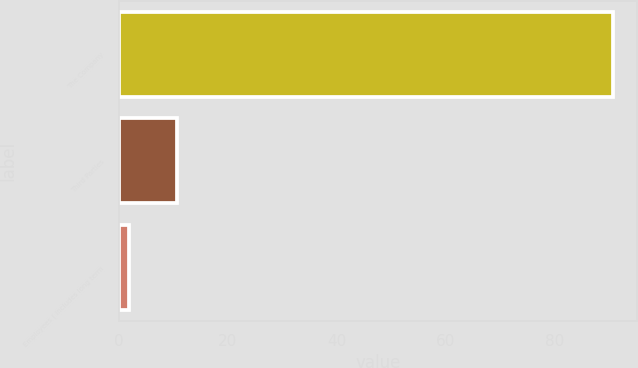<chart> <loc_0><loc_0><loc_500><loc_500><bar_chart><fcel>The Company<fcel>Third Parties<fcel>Employees ( includes long term<nl><fcel>90.7<fcel>10.78<fcel>1.9<nl></chart> 